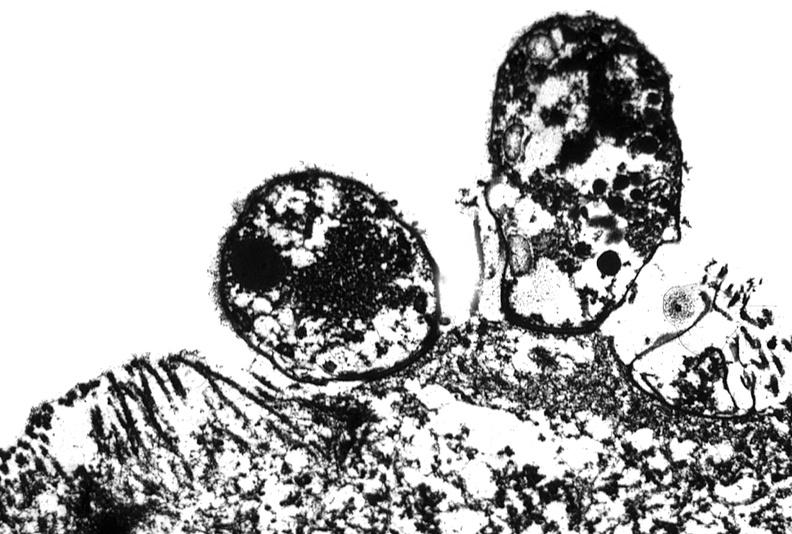what is present?
Answer the question using a single word or phrase. Gastrointestinal 